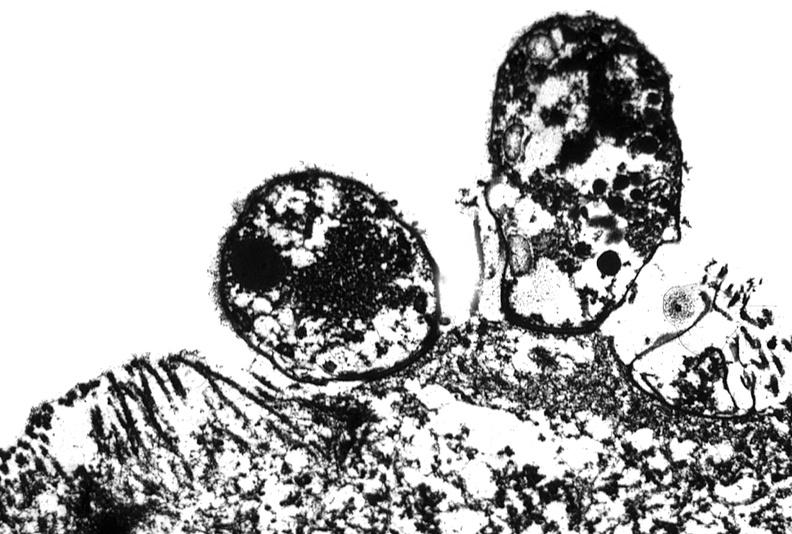what is present?
Answer the question using a single word or phrase. Gastrointestinal 